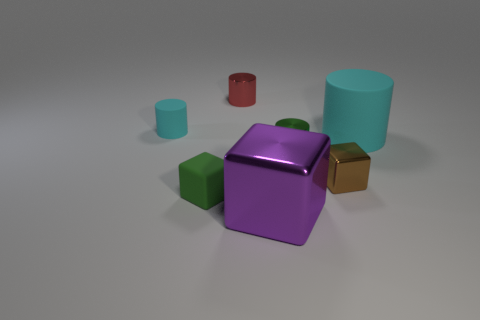Add 1 big purple objects. How many objects exist? 8 Subtract all cubes. How many objects are left? 4 Add 5 small metallic cylinders. How many small metallic cylinders are left? 7 Add 7 red rubber balls. How many red rubber balls exist? 7 Subtract 1 purple cubes. How many objects are left? 6 Subtract all cyan cylinders. Subtract all tiny blocks. How many objects are left? 3 